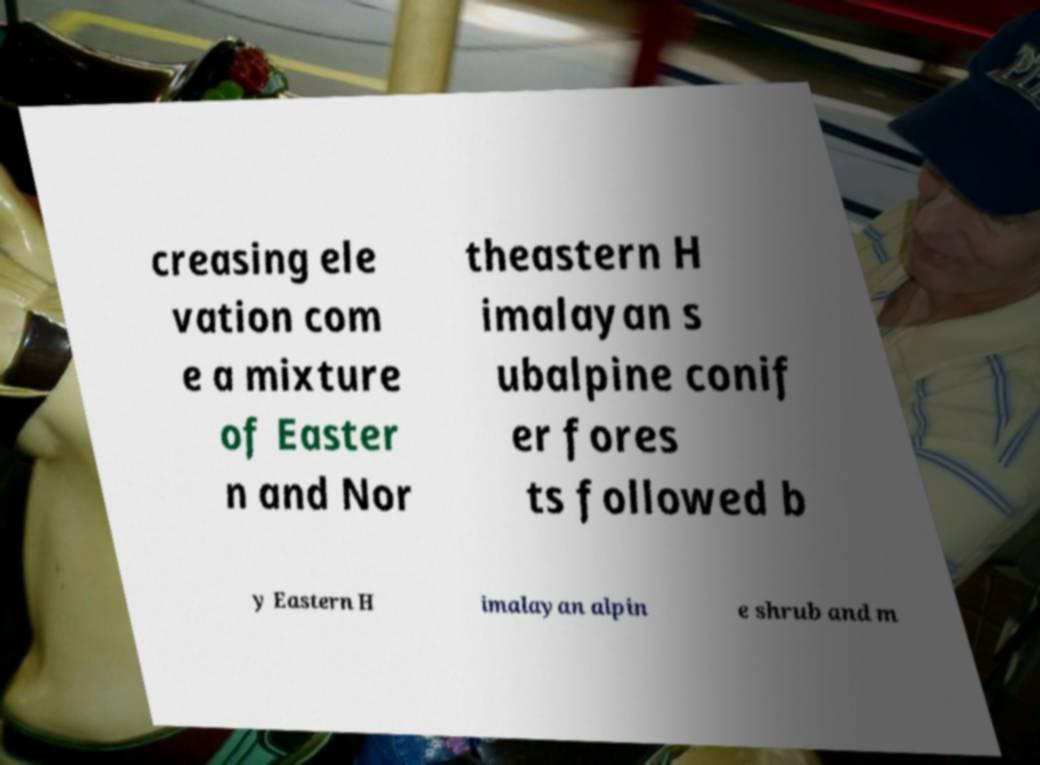What messages or text are displayed in this image? I need them in a readable, typed format. creasing ele vation com e a mixture of Easter n and Nor theastern H imalayan s ubalpine conif er fores ts followed b y Eastern H imalayan alpin e shrub and m 